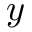Convert formula to latex. <formula><loc_0><loc_0><loc_500><loc_500>y</formula> 